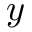Convert formula to latex. <formula><loc_0><loc_0><loc_500><loc_500>y</formula> 